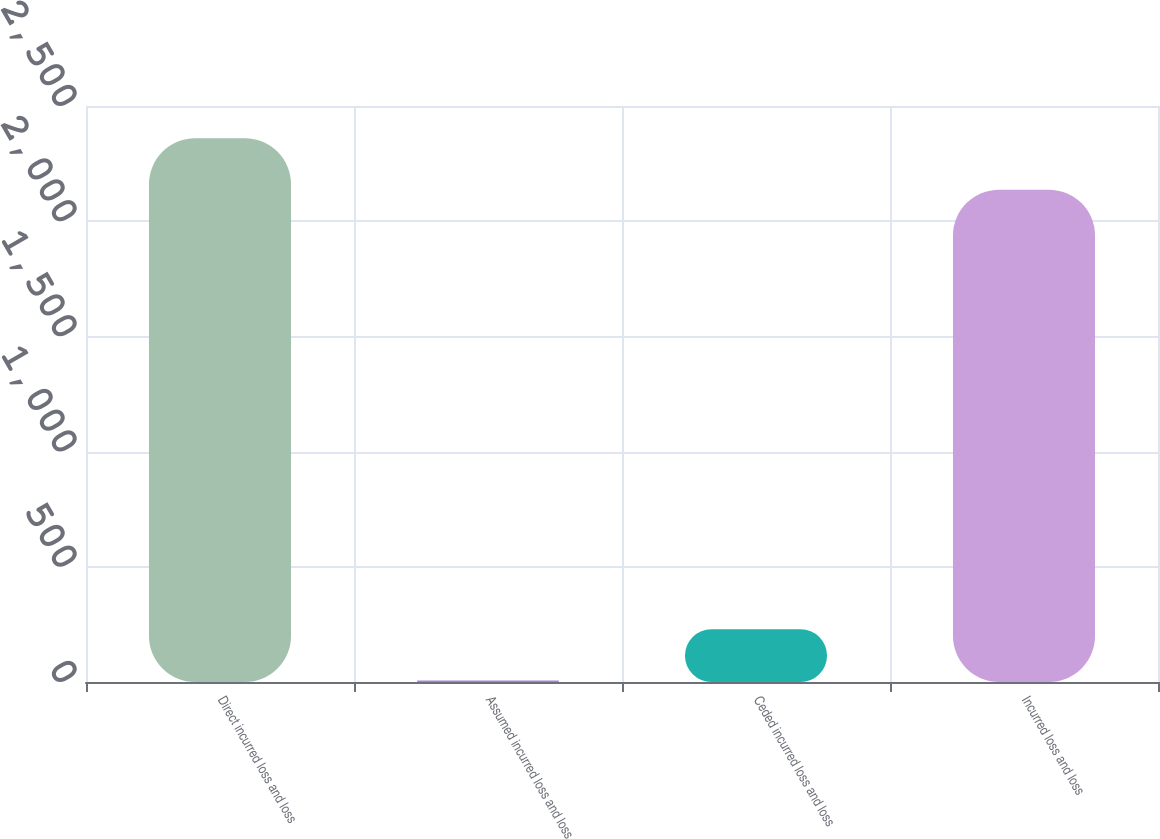Convert chart. <chart><loc_0><loc_0><loc_500><loc_500><bar_chart><fcel>Direct incurred loss and loss<fcel>Assumed incurred loss and loss<fcel>Ceded incurred loss and loss<fcel>Incurred loss and loss<nl><fcel>2359.9<fcel>6<fcel>228.9<fcel>2137<nl></chart> 